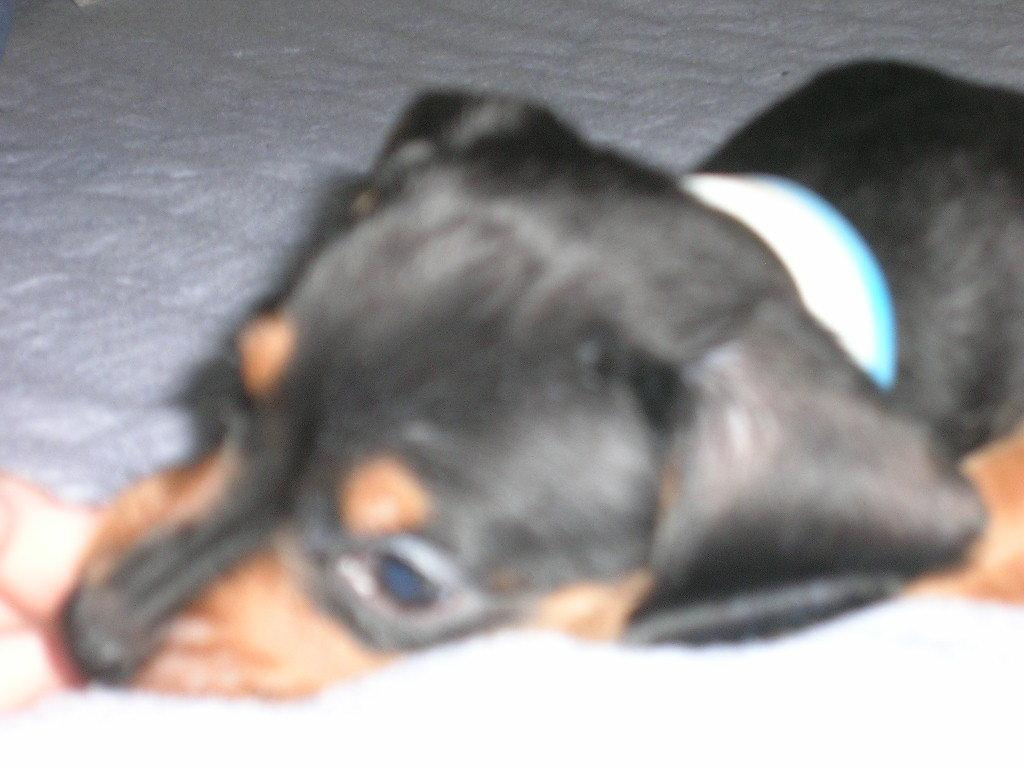What type of animal is present in the image? There is a dog in the image. What is the dog wearing? The dog is wearing a belt. Where is the dog located in the image? The dog is on the floor. What month is it in the image? The month is not mentioned or depicted in the image. What is the distance between the dog and the wall in the image? The distance between the dog and the wall is not mentioned or depicted in the image. 